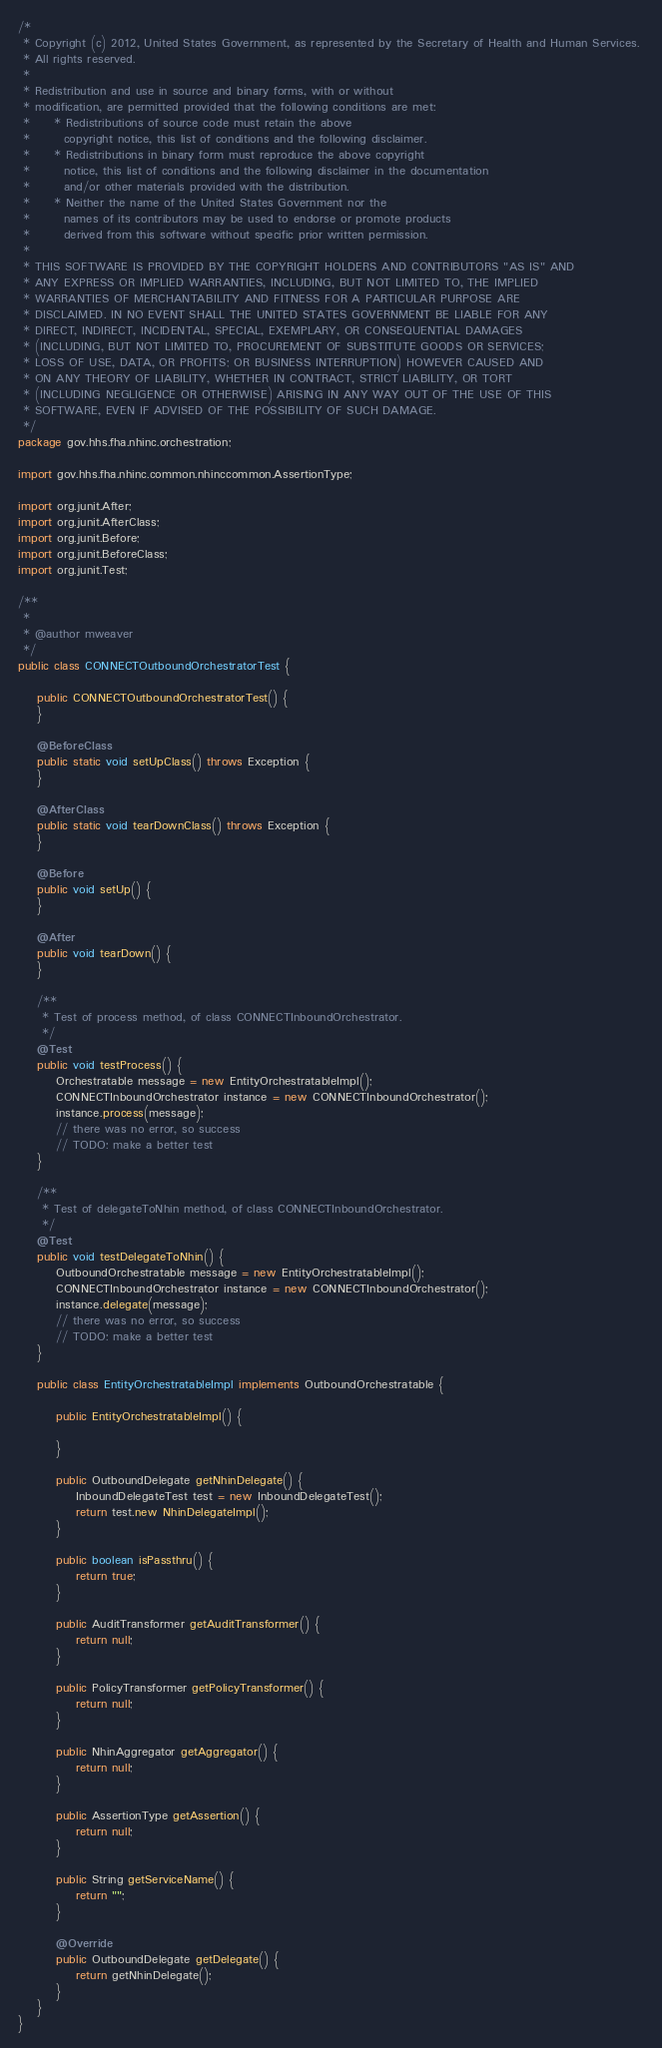Convert code to text. <code><loc_0><loc_0><loc_500><loc_500><_Java_>/*
 * Copyright (c) 2012, United States Government, as represented by the Secretary of Health and Human Services. 
 * All rights reserved. 
 *
 * Redistribution and use in source and binary forms, with or without 
 * modification, are permitted provided that the following conditions are met: 
 *     * Redistributions of source code must retain the above 
 *       copyright notice, this list of conditions and the following disclaimer. 
 *     * Redistributions in binary form must reproduce the above copyright 
 *       notice, this list of conditions and the following disclaimer in the documentation 
 *       and/or other materials provided with the distribution. 
 *     * Neither the name of the United States Government nor the 
 *       names of its contributors may be used to endorse or promote products 
 *       derived from this software without specific prior written permission. 
 *
 * THIS SOFTWARE IS PROVIDED BY THE COPYRIGHT HOLDERS AND CONTRIBUTORS "AS IS" AND 
 * ANY EXPRESS OR IMPLIED WARRANTIES, INCLUDING, BUT NOT LIMITED TO, THE IMPLIED 
 * WARRANTIES OF MERCHANTABILITY AND FITNESS FOR A PARTICULAR PURPOSE ARE 
 * DISCLAIMED. IN NO EVENT SHALL THE UNITED STATES GOVERNMENT BE LIABLE FOR ANY 
 * DIRECT, INDIRECT, INCIDENTAL, SPECIAL, EXEMPLARY, OR CONSEQUENTIAL DAMAGES 
 * (INCLUDING, BUT NOT LIMITED TO, PROCUREMENT OF SUBSTITUTE GOODS OR SERVICES; 
 * LOSS OF USE, DATA, OR PROFITS; OR BUSINESS INTERRUPTION) HOWEVER CAUSED AND 
 * ON ANY THEORY OF LIABILITY, WHETHER IN CONTRACT, STRICT LIABILITY, OR TORT 
 * (INCLUDING NEGLIGENCE OR OTHERWISE) ARISING IN ANY WAY OUT OF THE USE OF THIS 
 * SOFTWARE, EVEN IF ADVISED OF THE POSSIBILITY OF SUCH DAMAGE. 
 */
package gov.hhs.fha.nhinc.orchestration;

import gov.hhs.fha.nhinc.common.nhinccommon.AssertionType;

import org.junit.After;
import org.junit.AfterClass;
import org.junit.Before;
import org.junit.BeforeClass;
import org.junit.Test;

/**
 * 
 * @author mweaver
 */
public class CONNECTOutboundOrchestratorTest {

    public CONNECTOutboundOrchestratorTest() {
    }

    @BeforeClass
    public static void setUpClass() throws Exception {
    }

    @AfterClass
    public static void tearDownClass() throws Exception {
    }

    @Before
    public void setUp() {
    }

    @After
    public void tearDown() {
    }

    /**
     * Test of process method, of class CONNECTInboundOrchestrator.
     */
    @Test
    public void testProcess() {
        Orchestratable message = new EntityOrchestratableImpl();
        CONNECTInboundOrchestrator instance = new CONNECTInboundOrchestrator();
        instance.process(message);
        // there was no error, so success
        // TODO: make a better test
    }

    /**
     * Test of delegateToNhin method, of class CONNECTInboundOrchestrator.
     */
    @Test
    public void testDelegateToNhin() {
        OutboundOrchestratable message = new EntityOrchestratableImpl();
        CONNECTInboundOrchestrator instance = new CONNECTInboundOrchestrator();
        instance.delegate(message);
        // there was no error, so success
        // TODO: make a better test
    }

    public class EntityOrchestratableImpl implements OutboundOrchestratable {

        public EntityOrchestratableImpl() {

        }

        public OutboundDelegate getNhinDelegate() {
            InboundDelegateTest test = new InboundDelegateTest();
            return test.new NhinDelegateImpl();
        }

        public boolean isPassthru() {
            return true;
        }

        public AuditTransformer getAuditTransformer() {
            return null;
        }

        public PolicyTransformer getPolicyTransformer() {
            return null;
        }

        public NhinAggregator getAggregator() {
            return null;
        }

        public AssertionType getAssertion() {
            return null;
        }

        public String getServiceName() {
            return "";
        }

        @Override
        public OutboundDelegate getDelegate() {
            return getNhinDelegate();
        }
    }
}</code> 